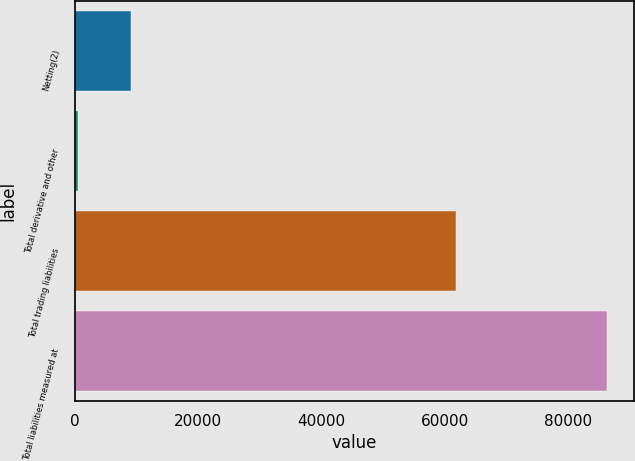Convert chart to OTSL. <chart><loc_0><loc_0><loc_500><loc_500><bar_chart><fcel>Netting(2)<fcel>Total derivative and other<fcel>Total trading liabilities<fcel>Total liabilities measured at<nl><fcel>9112.5<fcel>532<fcel>61788<fcel>86337<nl></chart> 